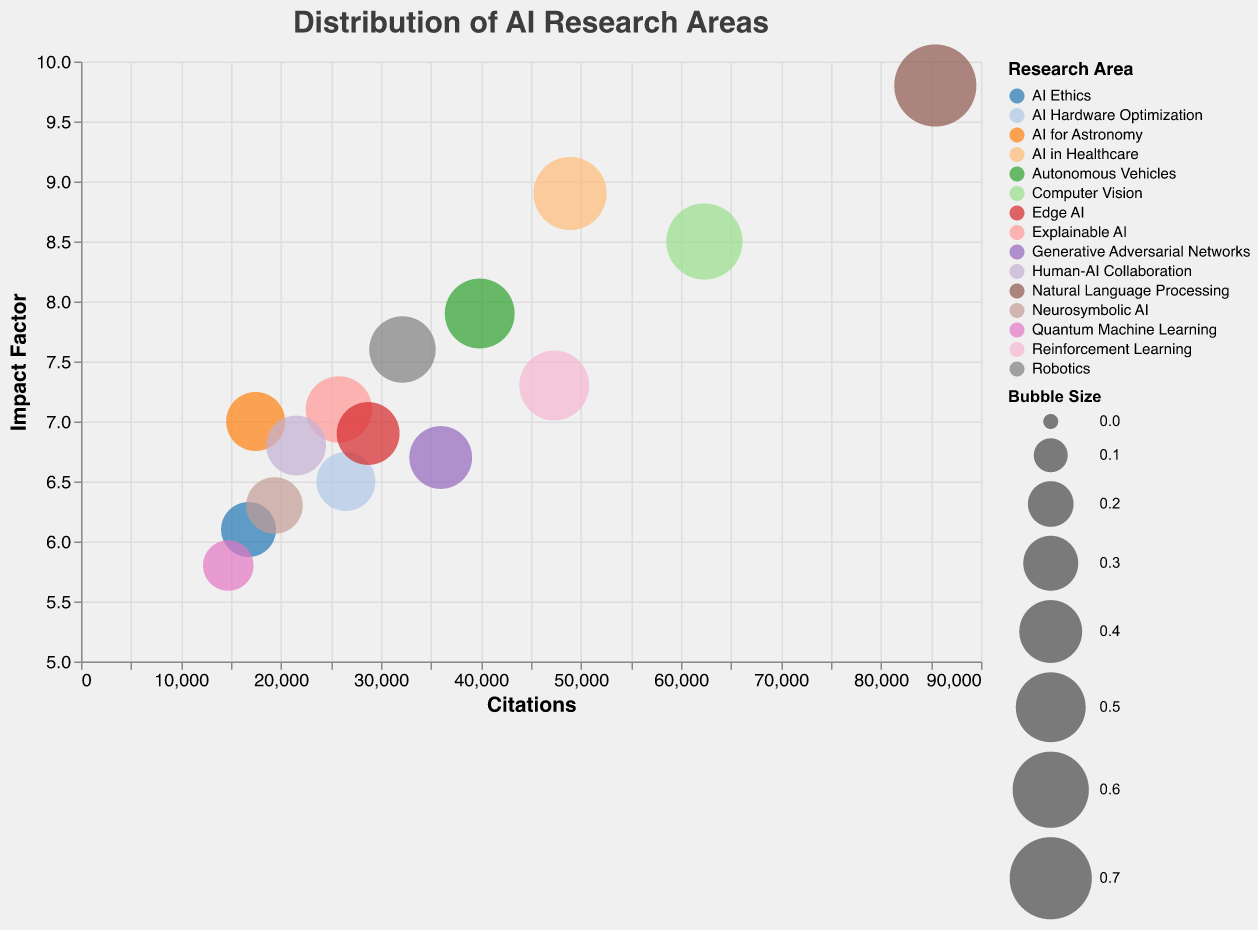How many research areas are represented on the chart? Count the distinct bubbles, each representing a different research area; there are 15 distinct bubbles, corresponding to 15 research areas in the dataset.
Answer: 15 Which research area has the highest number of citations? Identify the bubble farthest to the right on the x-axis, which represents the number of citations; "Natural Language Processing" is the rightmost bubble with 85,432 citations.
Answer: Natural Language Processing What is the impact factor range displayed on the y-axis? Observe the y-axis's minimum and maximum values; it ranges from 5 to 10.
Answer: 5 to 10 Which research area has the smallest bubble size, and what does that size represent? Look for the smallest bubble on the chart, which represents "Quantum Machine Learning" with a bubble size of 0.25, indicating this research area.
Answer: Quantum Machine Learning; 0.25 Compare the citation counts of Computer Vision and AI Ethics. Which one has more, and by how much? Locate the bubbles representing these areas and read off their citation counts: Computer Vision has 62,341 citations, while AI Ethics has 16,754 citations. Subtract the smaller from the larger (62,341 - 16,754 = 45,587).
Answer: Computer Vision; 45,587 Considering the impact factor, which research area has the closest value to 7.0? Identify the bubble near the 7.0 mark on the y-axis, which corresponds to "AI for Astronomy" with an impact factor of exactly 7.0.
Answer: AI for Astronomy Which research area has the highest impact factor and what is its value? Locate the bubble highest on the y-axis, which corresponds to "Natural Language Processing" with an impact factor of 9.8.
Answer: Natural Language Processing; 9.8 List the research areas with both citations greater than 30,000 and an impact factor higher than 8.0. Identify bubbles meeting these criteria: "Natural Language Processing" (85,432 citations, 9.8 impact factor), "Computer Vision" (62,341 citations, 8.5 impact factor), "AI in Healthcare" (48,906 citations, 8.9 impact factor), "Autonomous Vehicles" (39,872 citations, 7.9 impact factor is close but not higher than 8.0, so not included).
Answer: Natural Language Processing, Computer Vision, AI in Healthcare Calculate the average impact factor for "Explainable AI," "Robotics," and "Edge AI." Extract their impact factors: Explainable AI (7.1), Robotics (7.6), Edge AI (6.9). Sum them up (7.1 + 7.6 + 6.9 = 21.6) and divide by the number of areas (3); the average impact factor is 21.6 / 3 = 7.2.
Answer: 7.2 Which research area has a bubble size of 0.45 and what is its impact factor? Look for the bubbles with size 0.45: "Explainable AI" and "Robotics," both have this bubble size. Their impact factors are 7.1 and 7.6 respectively.
Answer: Explainable AI, Robotics; 7.1, 7.6 